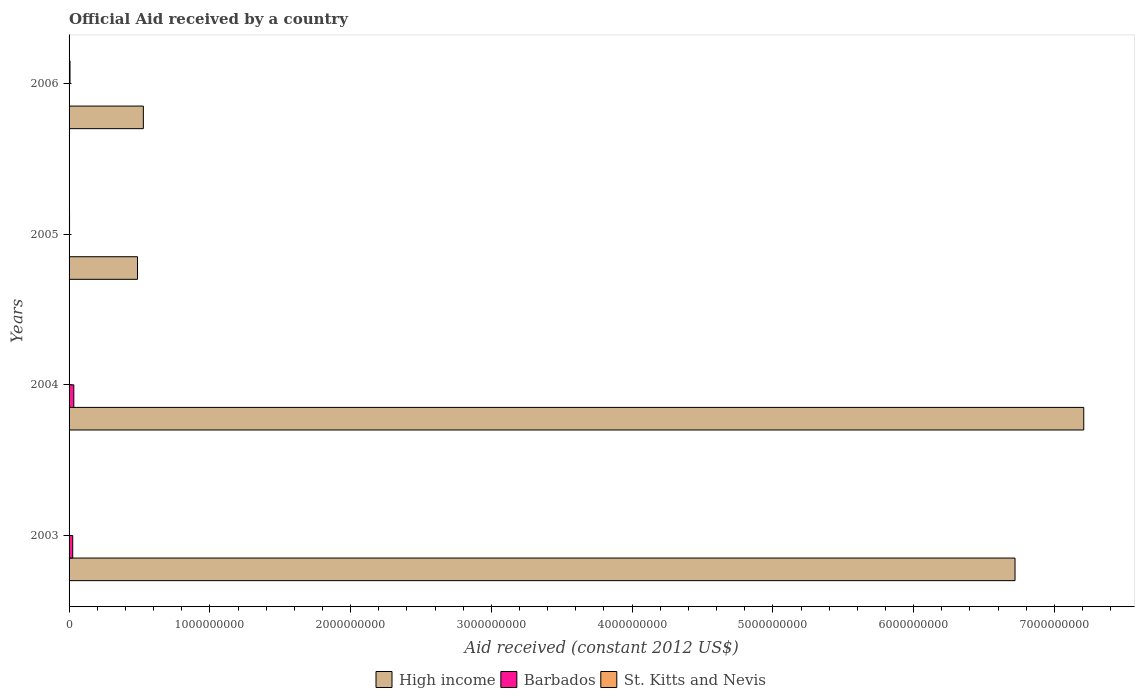How many groups of bars are there?
Keep it short and to the point. 4. Are the number of bars per tick equal to the number of legend labels?
Give a very brief answer. No. Are the number of bars on each tick of the Y-axis equal?
Offer a terse response. No. How many bars are there on the 1st tick from the top?
Ensure brevity in your answer.  2. What is the net official aid received in High income in 2004?
Provide a short and direct response. 7.21e+09. Across all years, what is the maximum net official aid received in Barbados?
Keep it short and to the point. 3.37e+07. In which year was the net official aid received in Barbados maximum?
Your answer should be compact. 2004. What is the total net official aid received in High income in the graph?
Offer a very short reply. 1.49e+1. What is the difference between the net official aid received in St. Kitts and Nevis in 2005 and that in 2006?
Provide a short and direct response. -3.36e+06. What is the difference between the net official aid received in Barbados in 2005 and the net official aid received in High income in 2003?
Give a very brief answer. -6.72e+09. What is the average net official aid received in High income per year?
Offer a very short reply. 3.74e+09. In the year 2003, what is the difference between the net official aid received in Barbados and net official aid received in High income?
Offer a terse response. -6.69e+09. In how many years, is the net official aid received in High income greater than 4200000000 US$?
Offer a terse response. 2. What is the ratio of the net official aid received in St. Kitts and Nevis in 2003 to that in 2006?
Ensure brevity in your answer.  0.05. What is the difference between the highest and the second highest net official aid received in High income?
Offer a very short reply. 4.88e+08. What is the difference between the highest and the lowest net official aid received in Barbados?
Provide a short and direct response. 3.37e+07. Is the sum of the net official aid received in St. Kitts and Nevis in 2004 and 2005 greater than the maximum net official aid received in High income across all years?
Offer a very short reply. No. How many bars are there?
Offer a terse response. 10. Are all the bars in the graph horizontal?
Your answer should be compact. Yes. How many years are there in the graph?
Keep it short and to the point. 4. How are the legend labels stacked?
Your answer should be compact. Horizontal. What is the title of the graph?
Your answer should be very brief. Official Aid received by a country. What is the label or title of the X-axis?
Provide a succinct answer. Aid received (constant 2012 US$). What is the Aid received (constant 2012 US$) of High income in 2003?
Provide a short and direct response. 6.72e+09. What is the Aid received (constant 2012 US$) of Barbados in 2003?
Make the answer very short. 2.60e+07. What is the Aid received (constant 2012 US$) in High income in 2004?
Your answer should be very brief. 7.21e+09. What is the Aid received (constant 2012 US$) of Barbados in 2004?
Give a very brief answer. 3.37e+07. What is the Aid received (constant 2012 US$) in High income in 2005?
Make the answer very short. 4.86e+08. What is the Aid received (constant 2012 US$) in Barbados in 2005?
Give a very brief answer. 0. What is the Aid received (constant 2012 US$) of St. Kitts and Nevis in 2005?
Provide a short and direct response. 3.38e+06. What is the Aid received (constant 2012 US$) in High income in 2006?
Ensure brevity in your answer.  5.28e+08. What is the Aid received (constant 2012 US$) in St. Kitts and Nevis in 2006?
Offer a very short reply. 6.74e+06. Across all years, what is the maximum Aid received (constant 2012 US$) of High income?
Your answer should be very brief. 7.21e+09. Across all years, what is the maximum Aid received (constant 2012 US$) in Barbados?
Offer a terse response. 3.37e+07. Across all years, what is the maximum Aid received (constant 2012 US$) of St. Kitts and Nevis?
Provide a short and direct response. 6.74e+06. Across all years, what is the minimum Aid received (constant 2012 US$) of High income?
Your answer should be very brief. 4.86e+08. Across all years, what is the minimum Aid received (constant 2012 US$) in Barbados?
Offer a very short reply. 0. Across all years, what is the minimum Aid received (constant 2012 US$) of St. Kitts and Nevis?
Keep it short and to the point. 1.00e+05. What is the total Aid received (constant 2012 US$) of High income in the graph?
Provide a succinct answer. 1.49e+1. What is the total Aid received (constant 2012 US$) of Barbados in the graph?
Keep it short and to the point. 5.97e+07. What is the total Aid received (constant 2012 US$) of St. Kitts and Nevis in the graph?
Offer a very short reply. 1.06e+07. What is the difference between the Aid received (constant 2012 US$) in High income in 2003 and that in 2004?
Make the answer very short. -4.88e+08. What is the difference between the Aid received (constant 2012 US$) in Barbados in 2003 and that in 2004?
Ensure brevity in your answer.  -7.69e+06. What is the difference between the Aid received (constant 2012 US$) of St. Kitts and Nevis in 2003 and that in 2004?
Keep it short and to the point. 2.30e+05. What is the difference between the Aid received (constant 2012 US$) in High income in 2003 and that in 2005?
Ensure brevity in your answer.  6.23e+09. What is the difference between the Aid received (constant 2012 US$) in St. Kitts and Nevis in 2003 and that in 2005?
Make the answer very short. -3.05e+06. What is the difference between the Aid received (constant 2012 US$) in High income in 2003 and that in 2006?
Offer a very short reply. 6.19e+09. What is the difference between the Aid received (constant 2012 US$) in St. Kitts and Nevis in 2003 and that in 2006?
Offer a very short reply. -6.41e+06. What is the difference between the Aid received (constant 2012 US$) of High income in 2004 and that in 2005?
Offer a terse response. 6.72e+09. What is the difference between the Aid received (constant 2012 US$) of St. Kitts and Nevis in 2004 and that in 2005?
Give a very brief answer. -3.28e+06. What is the difference between the Aid received (constant 2012 US$) in High income in 2004 and that in 2006?
Offer a very short reply. 6.68e+09. What is the difference between the Aid received (constant 2012 US$) in St. Kitts and Nevis in 2004 and that in 2006?
Offer a very short reply. -6.64e+06. What is the difference between the Aid received (constant 2012 US$) in High income in 2005 and that in 2006?
Make the answer very short. -4.15e+07. What is the difference between the Aid received (constant 2012 US$) of St. Kitts and Nevis in 2005 and that in 2006?
Your response must be concise. -3.36e+06. What is the difference between the Aid received (constant 2012 US$) in High income in 2003 and the Aid received (constant 2012 US$) in Barbados in 2004?
Provide a succinct answer. 6.69e+09. What is the difference between the Aid received (constant 2012 US$) in High income in 2003 and the Aid received (constant 2012 US$) in St. Kitts and Nevis in 2004?
Your answer should be compact. 6.72e+09. What is the difference between the Aid received (constant 2012 US$) in Barbados in 2003 and the Aid received (constant 2012 US$) in St. Kitts and Nevis in 2004?
Make the answer very short. 2.59e+07. What is the difference between the Aid received (constant 2012 US$) of High income in 2003 and the Aid received (constant 2012 US$) of St. Kitts and Nevis in 2005?
Give a very brief answer. 6.72e+09. What is the difference between the Aid received (constant 2012 US$) of Barbados in 2003 and the Aid received (constant 2012 US$) of St. Kitts and Nevis in 2005?
Offer a terse response. 2.26e+07. What is the difference between the Aid received (constant 2012 US$) in High income in 2003 and the Aid received (constant 2012 US$) in St. Kitts and Nevis in 2006?
Offer a very short reply. 6.71e+09. What is the difference between the Aid received (constant 2012 US$) of Barbados in 2003 and the Aid received (constant 2012 US$) of St. Kitts and Nevis in 2006?
Offer a terse response. 1.93e+07. What is the difference between the Aid received (constant 2012 US$) in High income in 2004 and the Aid received (constant 2012 US$) in St. Kitts and Nevis in 2005?
Offer a very short reply. 7.20e+09. What is the difference between the Aid received (constant 2012 US$) in Barbados in 2004 and the Aid received (constant 2012 US$) in St. Kitts and Nevis in 2005?
Your answer should be very brief. 3.03e+07. What is the difference between the Aid received (constant 2012 US$) in High income in 2004 and the Aid received (constant 2012 US$) in St. Kitts and Nevis in 2006?
Your answer should be very brief. 7.20e+09. What is the difference between the Aid received (constant 2012 US$) in Barbados in 2004 and the Aid received (constant 2012 US$) in St. Kitts and Nevis in 2006?
Provide a short and direct response. 2.70e+07. What is the difference between the Aid received (constant 2012 US$) of High income in 2005 and the Aid received (constant 2012 US$) of St. Kitts and Nevis in 2006?
Your answer should be compact. 4.79e+08. What is the average Aid received (constant 2012 US$) of High income per year?
Make the answer very short. 3.74e+09. What is the average Aid received (constant 2012 US$) in Barbados per year?
Provide a succinct answer. 1.49e+07. What is the average Aid received (constant 2012 US$) of St. Kitts and Nevis per year?
Your response must be concise. 2.64e+06. In the year 2003, what is the difference between the Aid received (constant 2012 US$) of High income and Aid received (constant 2012 US$) of Barbados?
Offer a terse response. 6.69e+09. In the year 2003, what is the difference between the Aid received (constant 2012 US$) in High income and Aid received (constant 2012 US$) in St. Kitts and Nevis?
Offer a very short reply. 6.72e+09. In the year 2003, what is the difference between the Aid received (constant 2012 US$) in Barbados and Aid received (constant 2012 US$) in St. Kitts and Nevis?
Give a very brief answer. 2.57e+07. In the year 2004, what is the difference between the Aid received (constant 2012 US$) in High income and Aid received (constant 2012 US$) in Barbados?
Your answer should be compact. 7.17e+09. In the year 2004, what is the difference between the Aid received (constant 2012 US$) in High income and Aid received (constant 2012 US$) in St. Kitts and Nevis?
Give a very brief answer. 7.21e+09. In the year 2004, what is the difference between the Aid received (constant 2012 US$) in Barbados and Aid received (constant 2012 US$) in St. Kitts and Nevis?
Give a very brief answer. 3.36e+07. In the year 2005, what is the difference between the Aid received (constant 2012 US$) in High income and Aid received (constant 2012 US$) in St. Kitts and Nevis?
Your response must be concise. 4.83e+08. In the year 2006, what is the difference between the Aid received (constant 2012 US$) in High income and Aid received (constant 2012 US$) in St. Kitts and Nevis?
Give a very brief answer. 5.21e+08. What is the ratio of the Aid received (constant 2012 US$) in High income in 2003 to that in 2004?
Make the answer very short. 0.93. What is the ratio of the Aid received (constant 2012 US$) of Barbados in 2003 to that in 2004?
Ensure brevity in your answer.  0.77. What is the ratio of the Aid received (constant 2012 US$) of High income in 2003 to that in 2005?
Offer a terse response. 13.82. What is the ratio of the Aid received (constant 2012 US$) of St. Kitts and Nevis in 2003 to that in 2005?
Provide a short and direct response. 0.1. What is the ratio of the Aid received (constant 2012 US$) in High income in 2003 to that in 2006?
Offer a terse response. 12.74. What is the ratio of the Aid received (constant 2012 US$) of St. Kitts and Nevis in 2003 to that in 2006?
Provide a short and direct response. 0.05. What is the ratio of the Aid received (constant 2012 US$) in High income in 2004 to that in 2005?
Provide a short and direct response. 14.83. What is the ratio of the Aid received (constant 2012 US$) in St. Kitts and Nevis in 2004 to that in 2005?
Your answer should be very brief. 0.03. What is the ratio of the Aid received (constant 2012 US$) in High income in 2004 to that in 2006?
Make the answer very short. 13.66. What is the ratio of the Aid received (constant 2012 US$) in St. Kitts and Nevis in 2004 to that in 2006?
Ensure brevity in your answer.  0.01. What is the ratio of the Aid received (constant 2012 US$) of High income in 2005 to that in 2006?
Your response must be concise. 0.92. What is the ratio of the Aid received (constant 2012 US$) in St. Kitts and Nevis in 2005 to that in 2006?
Keep it short and to the point. 0.5. What is the difference between the highest and the second highest Aid received (constant 2012 US$) in High income?
Give a very brief answer. 4.88e+08. What is the difference between the highest and the second highest Aid received (constant 2012 US$) of St. Kitts and Nevis?
Your answer should be compact. 3.36e+06. What is the difference between the highest and the lowest Aid received (constant 2012 US$) of High income?
Provide a short and direct response. 6.72e+09. What is the difference between the highest and the lowest Aid received (constant 2012 US$) of Barbados?
Give a very brief answer. 3.37e+07. What is the difference between the highest and the lowest Aid received (constant 2012 US$) in St. Kitts and Nevis?
Your answer should be very brief. 6.64e+06. 